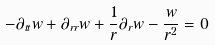<formula> <loc_0><loc_0><loc_500><loc_500>- \partial _ { t t } w + \partial _ { r r } w + \frac { 1 } { r } \partial _ { r } w - \frac { w } { r ^ { 2 } } = 0</formula> 